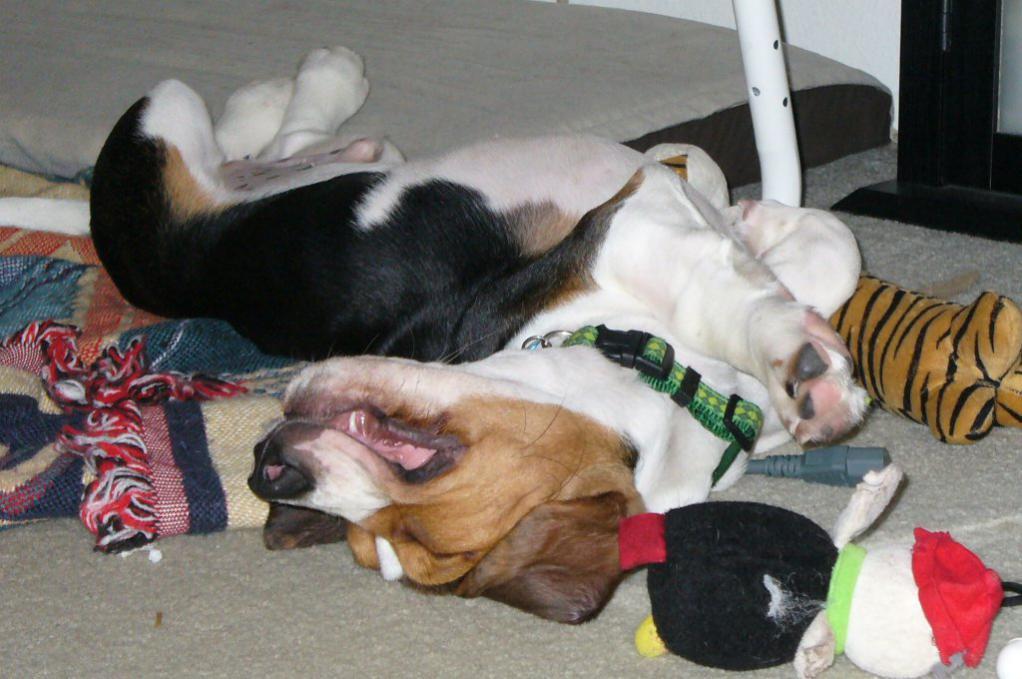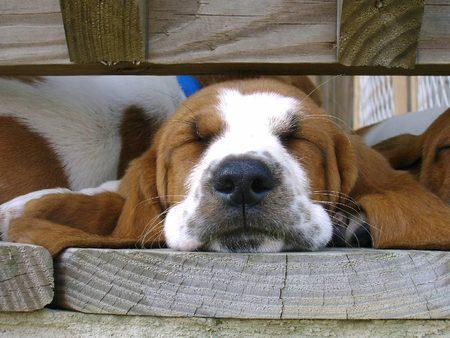The first image is the image on the left, the second image is the image on the right. Considering the images on both sides, is "Each image contains one basset hound, and one hound lies on his back while the other hound lies on his stomach with his head flat." valid? Answer yes or no. Yes. The first image is the image on the left, the second image is the image on the right. For the images displayed, is the sentence "In one of the images there is a Basset Hound sleeping on its tummy." factually correct? Answer yes or no. Yes. 